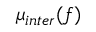Convert formula to latex. <formula><loc_0><loc_0><loc_500><loc_500>\mu _ { i n t e r } ( f )</formula> 